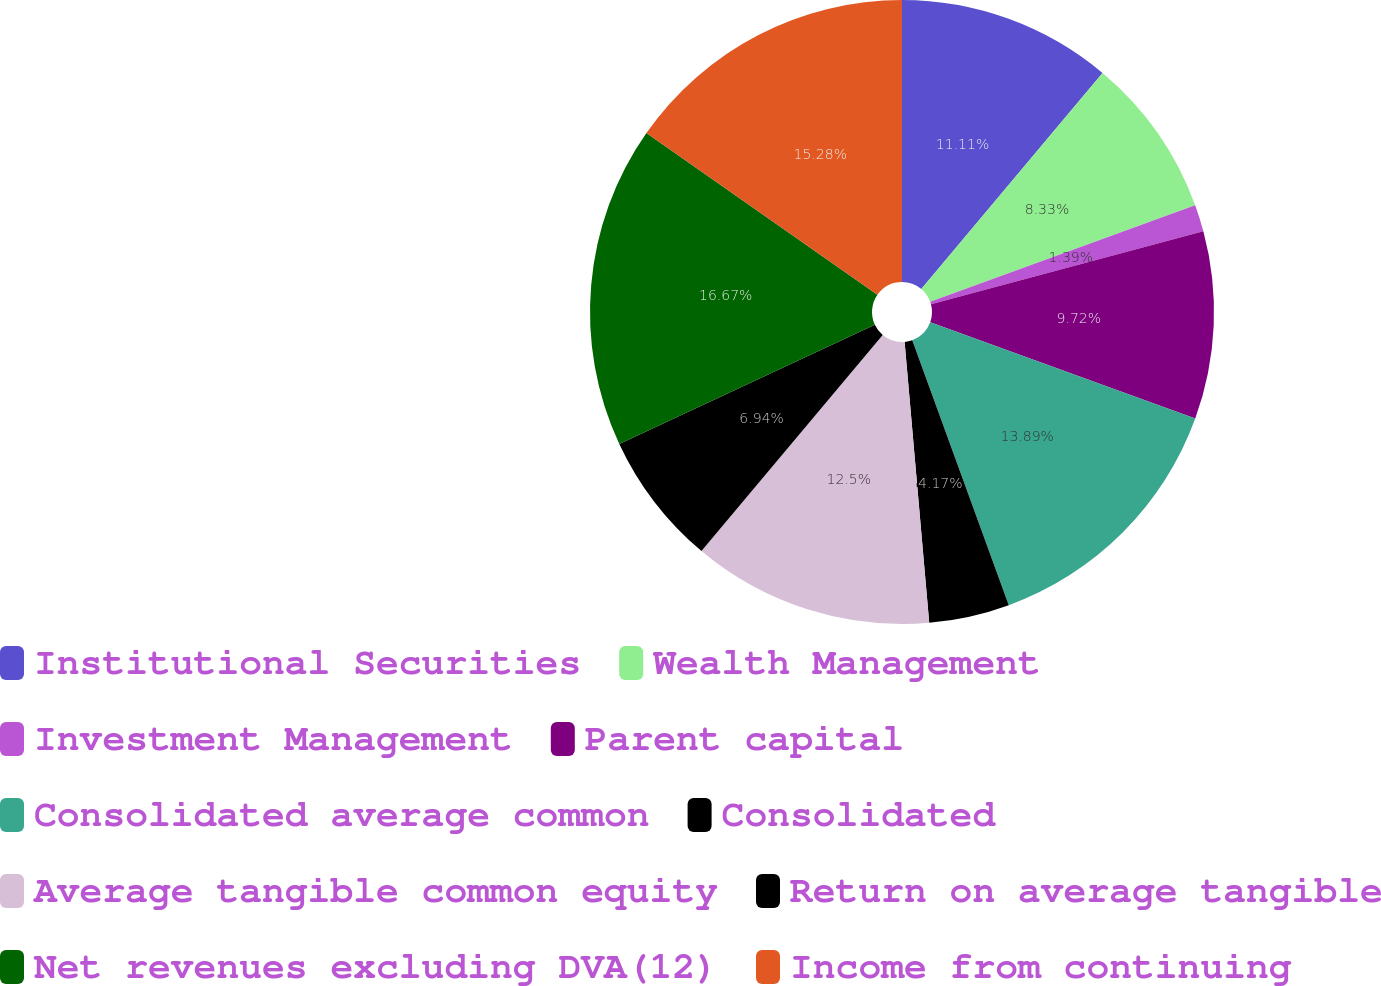<chart> <loc_0><loc_0><loc_500><loc_500><pie_chart><fcel>Institutional Securities<fcel>Wealth Management<fcel>Investment Management<fcel>Parent capital<fcel>Consolidated average common<fcel>Consolidated<fcel>Average tangible common equity<fcel>Return on average tangible<fcel>Net revenues excluding DVA(12)<fcel>Income from continuing<nl><fcel>11.11%<fcel>8.33%<fcel>1.39%<fcel>9.72%<fcel>13.89%<fcel>4.17%<fcel>12.5%<fcel>6.94%<fcel>16.67%<fcel>15.28%<nl></chart> 